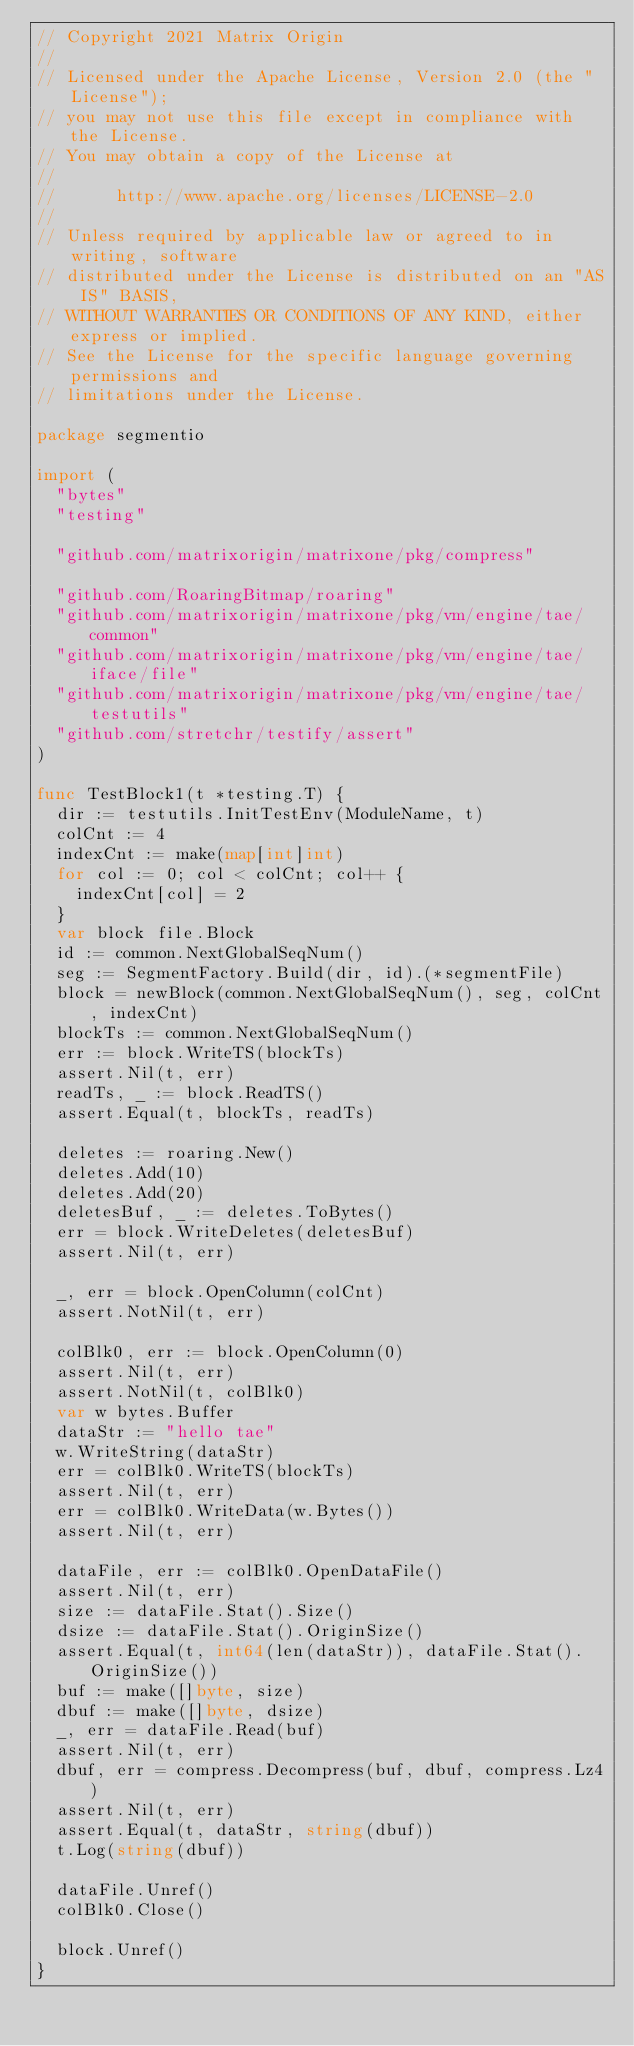Convert code to text. <code><loc_0><loc_0><loc_500><loc_500><_Go_>// Copyright 2021 Matrix Origin
//
// Licensed under the Apache License, Version 2.0 (the "License");
// you may not use this file except in compliance with the License.
// You may obtain a copy of the License at
//
//      http://www.apache.org/licenses/LICENSE-2.0
//
// Unless required by applicable law or agreed to in writing, software
// distributed under the License is distributed on an "AS IS" BASIS,
// WITHOUT WARRANTIES OR CONDITIONS OF ANY KIND, either express or implied.
// See the License for the specific language governing permissions and
// limitations under the License.

package segmentio

import (
	"bytes"
	"testing"

	"github.com/matrixorigin/matrixone/pkg/compress"

	"github.com/RoaringBitmap/roaring"
	"github.com/matrixorigin/matrixone/pkg/vm/engine/tae/common"
	"github.com/matrixorigin/matrixone/pkg/vm/engine/tae/iface/file"
	"github.com/matrixorigin/matrixone/pkg/vm/engine/tae/testutils"
	"github.com/stretchr/testify/assert"
)

func TestBlock1(t *testing.T) {
	dir := testutils.InitTestEnv(ModuleName, t)
	colCnt := 4
	indexCnt := make(map[int]int)
	for col := 0; col < colCnt; col++ {
		indexCnt[col] = 2
	}
	var block file.Block
	id := common.NextGlobalSeqNum()
	seg := SegmentFactory.Build(dir, id).(*segmentFile)
	block = newBlock(common.NextGlobalSeqNum(), seg, colCnt, indexCnt)
	blockTs := common.NextGlobalSeqNum()
	err := block.WriteTS(blockTs)
	assert.Nil(t, err)
	readTs, _ := block.ReadTS()
	assert.Equal(t, blockTs, readTs)

	deletes := roaring.New()
	deletes.Add(10)
	deletes.Add(20)
	deletesBuf, _ := deletes.ToBytes()
	err = block.WriteDeletes(deletesBuf)
	assert.Nil(t, err)

	_, err = block.OpenColumn(colCnt)
	assert.NotNil(t, err)

	colBlk0, err := block.OpenColumn(0)
	assert.Nil(t, err)
	assert.NotNil(t, colBlk0)
	var w bytes.Buffer
	dataStr := "hello tae"
	w.WriteString(dataStr)
	err = colBlk0.WriteTS(blockTs)
	assert.Nil(t, err)
	err = colBlk0.WriteData(w.Bytes())
	assert.Nil(t, err)

	dataFile, err := colBlk0.OpenDataFile()
	assert.Nil(t, err)
	size := dataFile.Stat().Size()
	dsize := dataFile.Stat().OriginSize()
	assert.Equal(t, int64(len(dataStr)), dataFile.Stat().OriginSize())
	buf := make([]byte, size)
	dbuf := make([]byte, dsize)
	_, err = dataFile.Read(buf)
	assert.Nil(t, err)
	dbuf, err = compress.Decompress(buf, dbuf, compress.Lz4)
	assert.Nil(t, err)
	assert.Equal(t, dataStr, string(dbuf))
	t.Log(string(dbuf))

	dataFile.Unref()
	colBlk0.Close()

	block.Unref()
}
</code> 